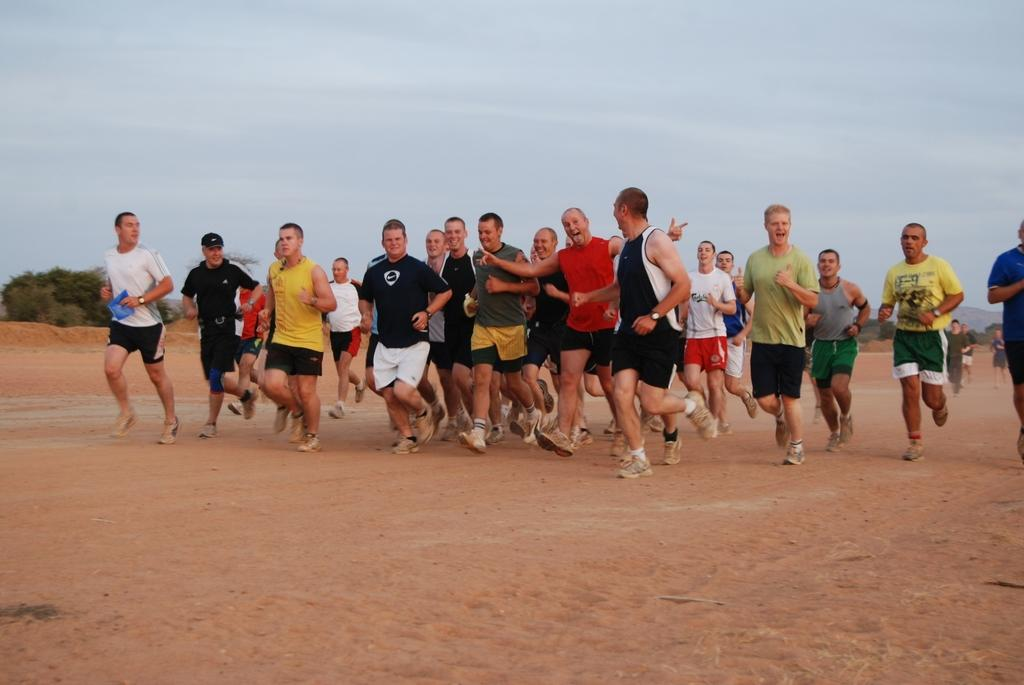How many people are in the image? There are people in the image, but the exact number is not specified. What type of clothing are the people wearing on their upper bodies? The people are wearing T-shirts in the image. What type of footwear are the people wearing? The people are wearing shoes in the image. What type of clothing are the people wearing on their feet? The people are wearing socks in the image. What activity are the people engaged in? The people are running on the sand in the image. What can be seen in the background of the image? There are trees, hills, and the sky visible in the background of the image. How many girls are running on the sand in the image? The provided facts do not specify the gender of the people in the image, so it is not possible to determine the number of girls running on the sand. Where is the faucet located in the image? There is no faucet present in the image. 